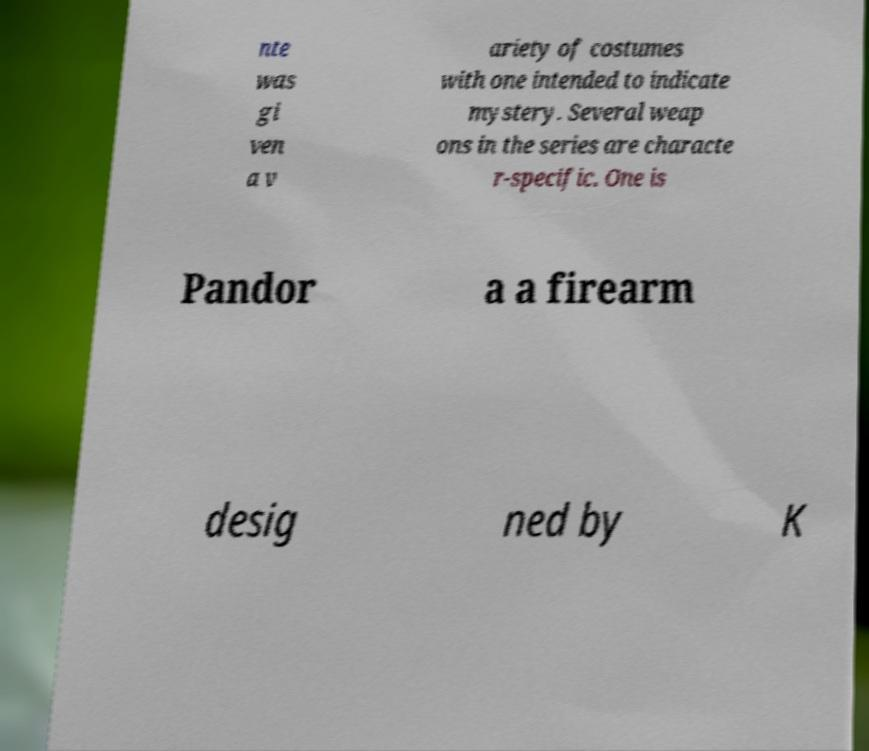Could you extract and type out the text from this image? nte was gi ven a v ariety of costumes with one intended to indicate mystery. Several weap ons in the series are characte r-specific. One is Pandor a a firearm desig ned by K 